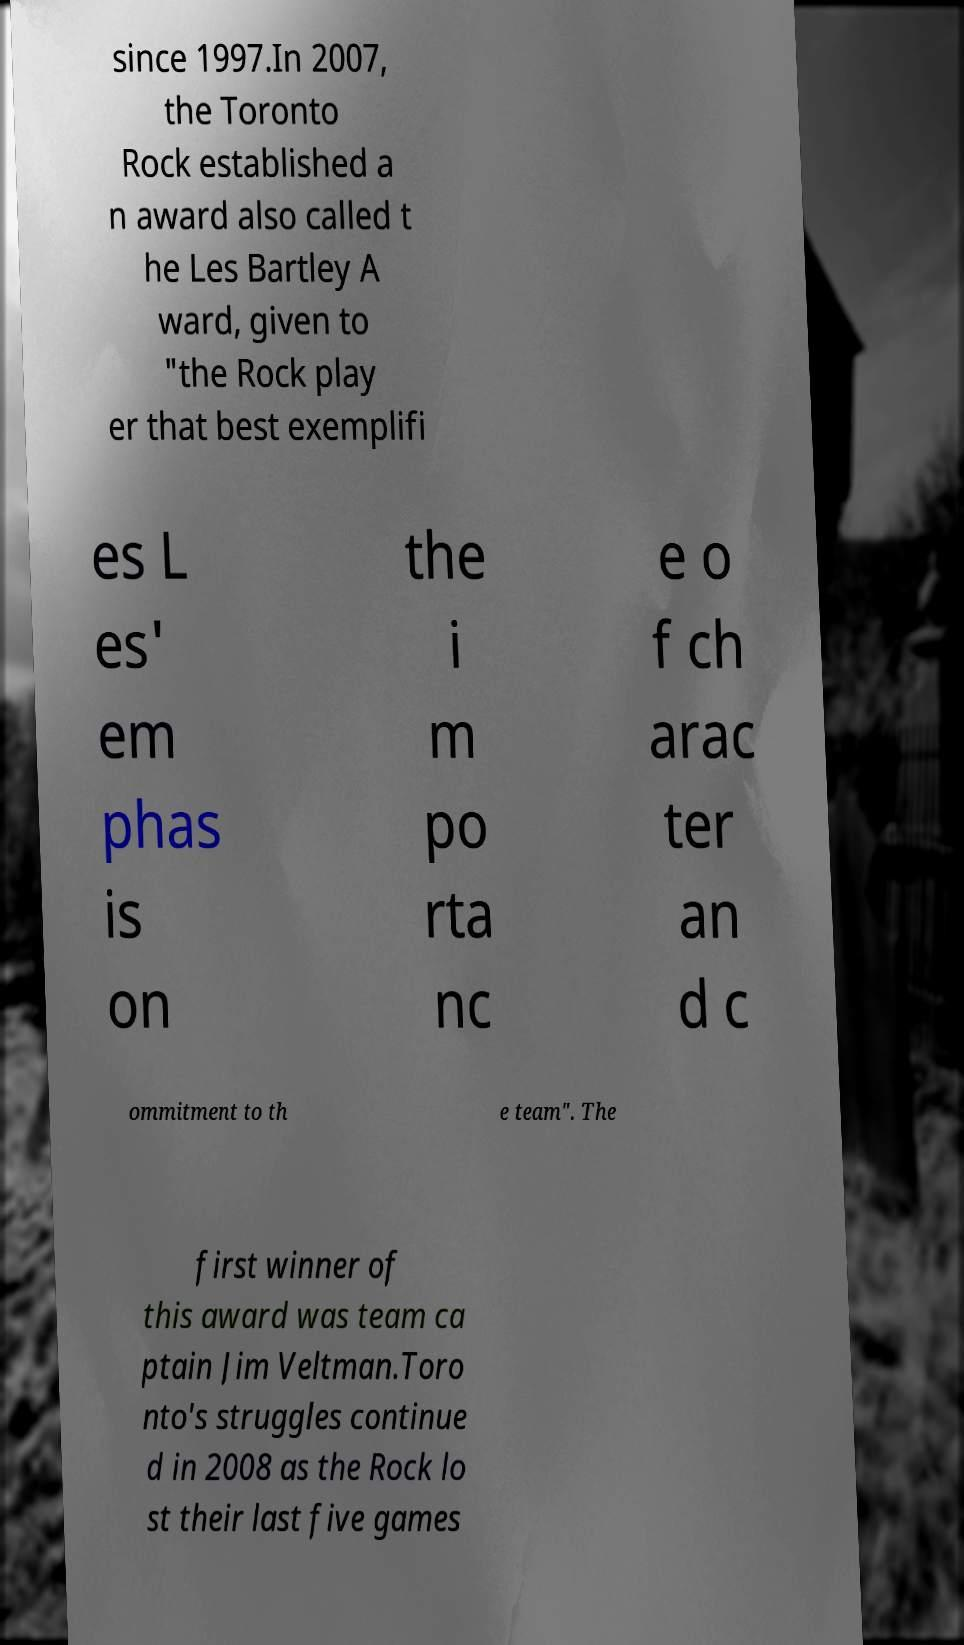For documentation purposes, I need the text within this image transcribed. Could you provide that? since 1997.In 2007, the Toronto Rock established a n award also called t he Les Bartley A ward, given to "the Rock play er that best exemplifi es L es' em phas is on the i m po rta nc e o f ch arac ter an d c ommitment to th e team". The first winner of this award was team ca ptain Jim Veltman.Toro nto's struggles continue d in 2008 as the Rock lo st their last five games 